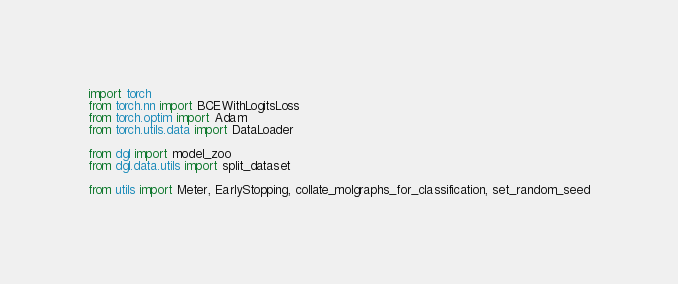<code> <loc_0><loc_0><loc_500><loc_500><_Python_>import torch
from torch.nn import BCEWithLogitsLoss
from torch.optim import Adam
from torch.utils.data import DataLoader

from dgl import model_zoo
from dgl.data.utils import split_dataset

from utils import Meter, EarlyStopping, collate_molgraphs_for_classification, set_random_seed
</code> 